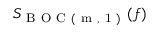Convert formula to latex. <formula><loc_0><loc_0><loc_500><loc_500>S _ { B O C ( m , 1 ) } ( f )</formula> 